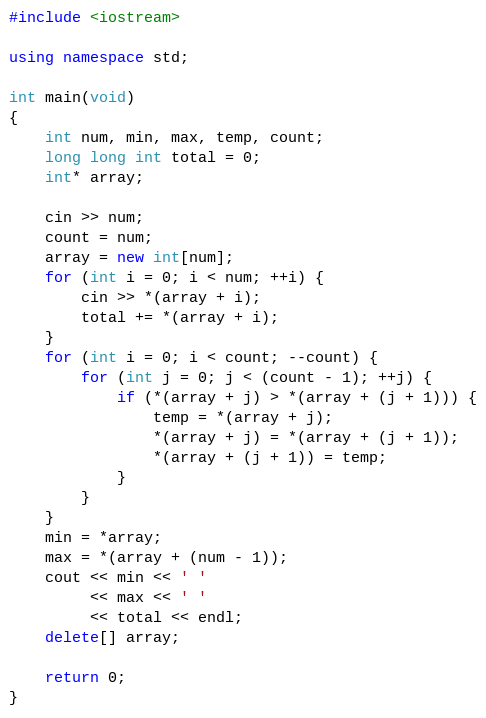<code> <loc_0><loc_0><loc_500><loc_500><_C++_>#include <iostream>

using namespace std;

int main(void)
{
    int num, min, max, temp, count;
    long long int total = 0;
    int* array;
    
    cin >> num;
    count = num;
    array = new int[num];
    for (int i = 0; i < num; ++i) {
        cin >> *(array + i);
        total += *(array + i);
    }
    for (int i = 0; i < count; --count) {
        for (int j = 0; j < (count - 1); ++j) {
            if (*(array + j) > *(array + (j + 1))) {
                temp = *(array + j);
                *(array + j) = *(array + (j + 1));
                *(array + (j + 1)) = temp;
            }
        }
    }
    min = *array;
    max = *(array + (num - 1));
    cout << min << ' '
         << max << ' '
         << total << endl;
    delete[] array;
    
    return 0;
}
</code> 